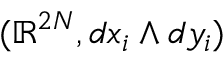Convert formula to latex. <formula><loc_0><loc_0><loc_500><loc_500>( \mathbb { R } ^ { 2 N } , d x _ { i } \wedge d y _ { i } )</formula> 